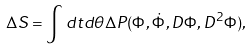<formula> <loc_0><loc_0><loc_500><loc_500>\Delta S = \int d t d \theta \Delta P ( \Phi , \dot { \Phi } , D \Phi , D ^ { 2 } \Phi ) ,</formula> 